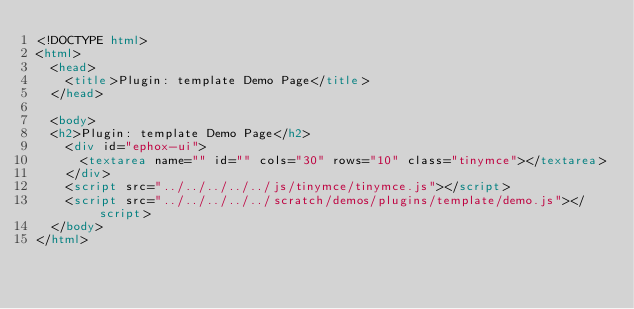<code> <loc_0><loc_0><loc_500><loc_500><_HTML_><!DOCTYPE html>
<html>
  <head>
    <title>Plugin: template Demo Page</title>
  </head>

  <body>
  <h2>Plugin: template Demo Page</h2>
    <div id="ephox-ui">
      <textarea name="" id="" cols="30" rows="10" class="tinymce"></textarea>
    </div>
    <script src="../../../../../js/tinymce/tinymce.js"></script>
    <script src="../../../../../scratch/demos/plugins/template/demo.js"></script>
  </body>
</html></code> 